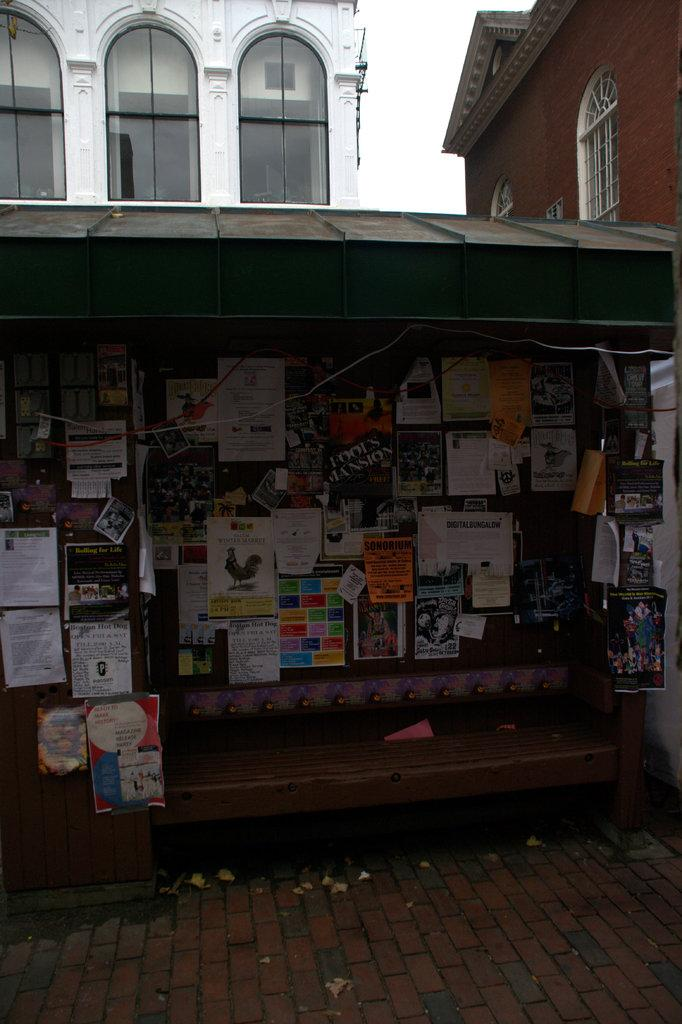What is located in the center of the image? There is a wall in the center of the image. What is on the wall? There are posters on the wall. What piece of furniture is present in the image? There is a bench in the image. What can be seen in the background of the image? There are buildings in the background of the image. What is at the bottom of the image? There is a walkway at the bottom of the image. What type of bread is being sold at the gate in the image? There is no gate or bread present in the image. What news is being reported on the posters in the image? The posters in the image do not contain any news; they are simply decorative. 